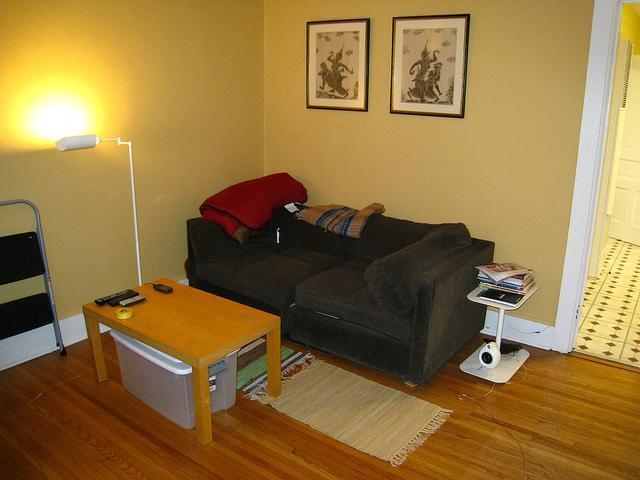How many people are wearing a white shirt?
Give a very brief answer. 0. 